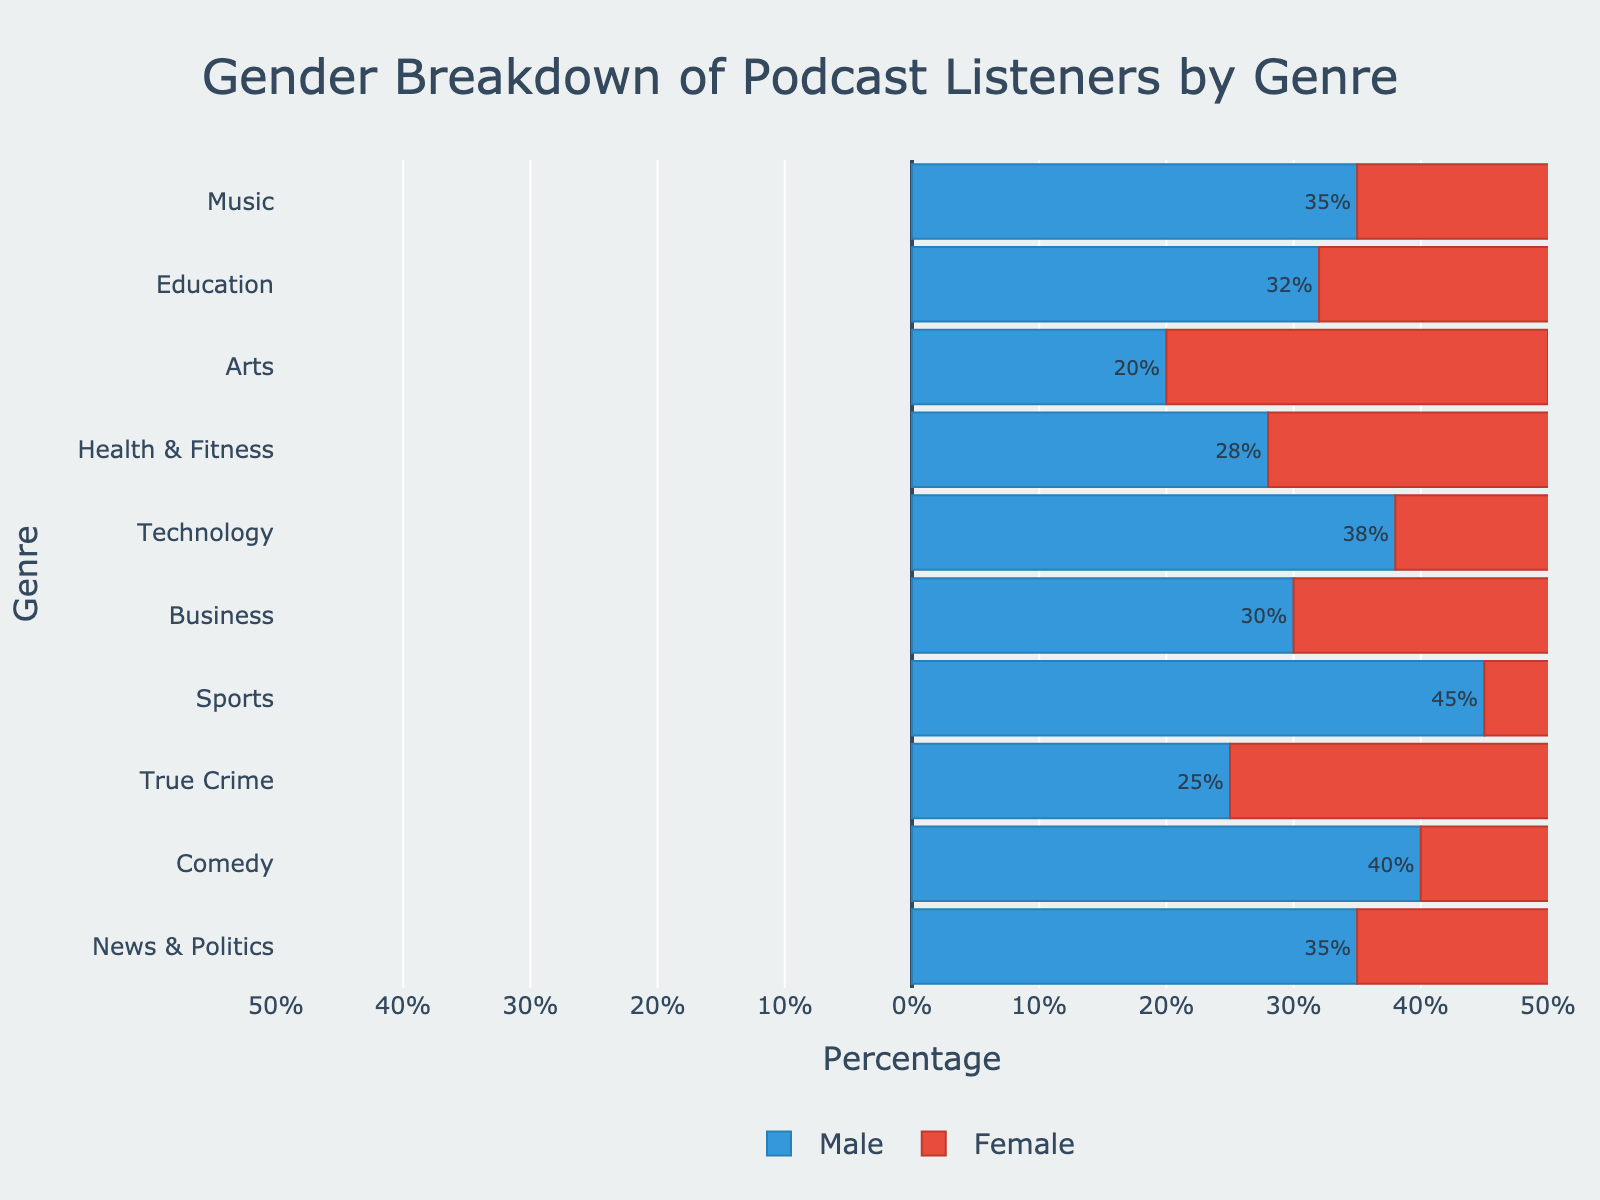Which genre has the highest percentage of male listeners? The Sports genre has the highest percentage of male listeners, as indicated by the longest bar on the positive side of the horizontal axis.
Answer: Sports Which genre has more female listeners: True Crime or Health & Fitness? Health & Fitness has more female listeners, as the negative bar for Health & Fitness extends longer than the one for True Crime.
Answer: Health & Fitness What is the total percentage of male and female listeners for the Comedy genre? The Comedy genre has 40% male and 45% female listeners. Adding them up gives 40 + 45 = 85%.
Answer: 85% Compare the percentage of male listeners in the Technology genre with the percentage of female listeners in the Business genre. Which one is higher? The Technology genre has 38% male listeners, while the Business genre has 25% female listeners. 38% (Technology) is higher than 25% (Business).
Answer: Technology Which genre has an equal percentage of male and female listeners? The Music genre has an equal percentage of male (35%) and female (35%) listeners, as shown by the lengths of the bars being the same on both sides of the axis.
Answer: Music Among News & Politics and Education genres, which has more male listeners? Education has more male listeners (32%) compared to News & Politics (35%), as indicated by the longer bar on the male side for News & Politics.
Answer: News & Politics In the genre with the lowest percentage of female listeners, what is the percentage of male listeners? The genre is the Sports genre with the lowest female listeners at 20%. The percentage of male listeners in the Sports genre is 45%.
Answer: 45% Which genre shows a larger disparity between male and female listeners: Comedy or Education? Comedy shows a larger disparity with 40% male and 45% female, a difference of 5%, while Education has 32% male and 38% female, a difference of 6%. Thus, Education shows a slightly larger disparity.
Answer: Education 